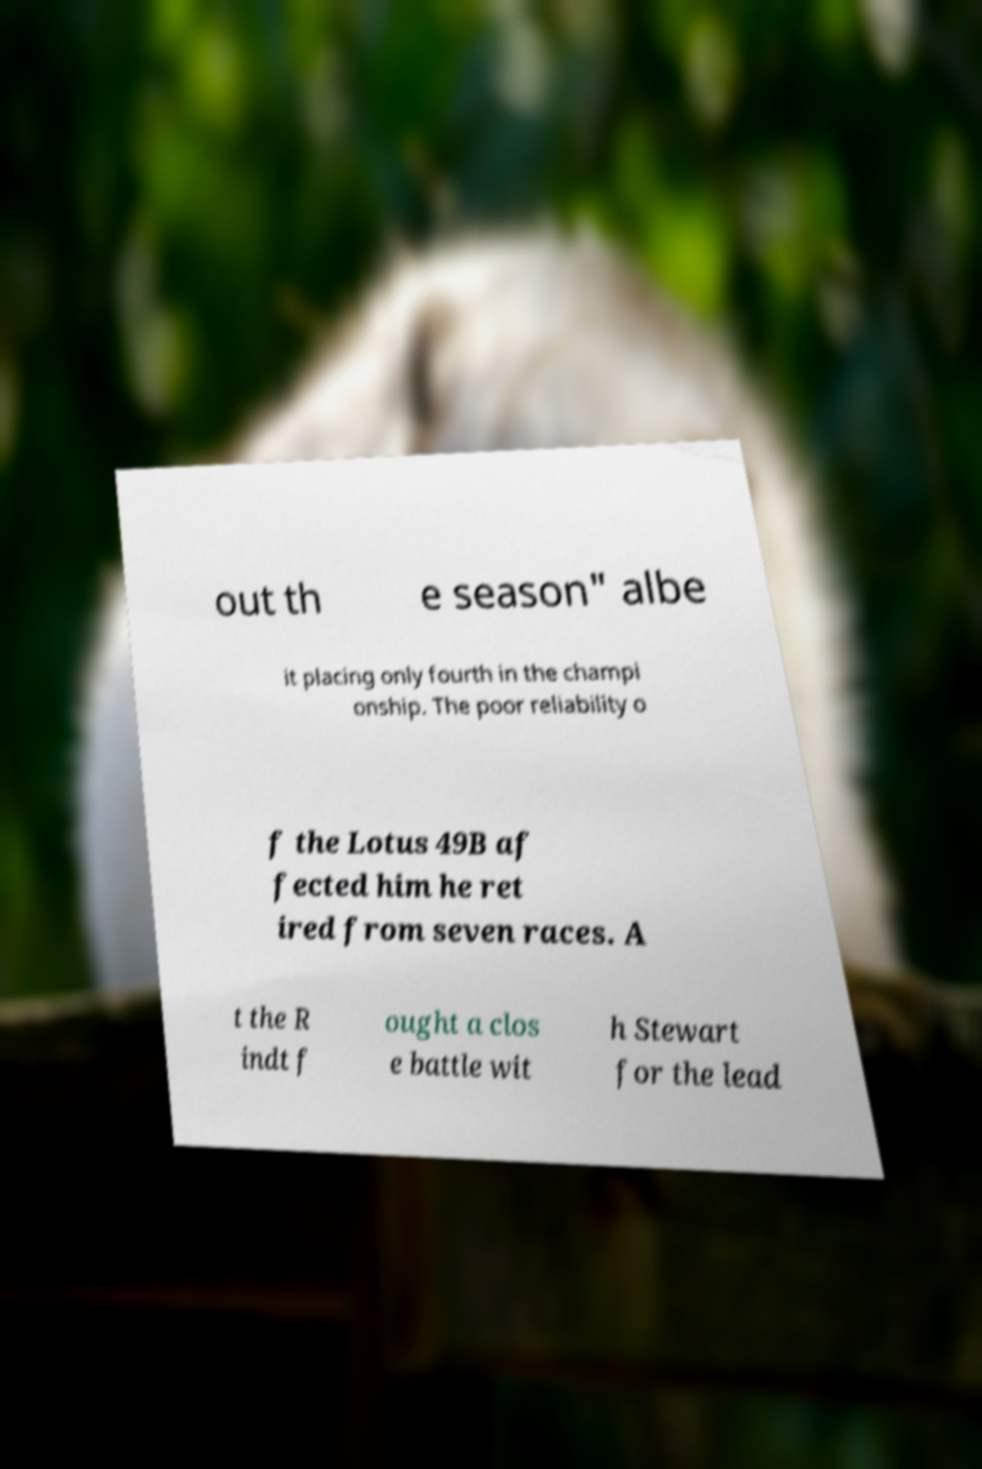Can you accurately transcribe the text from the provided image for me? out th e season" albe it placing only fourth in the champi onship. The poor reliability o f the Lotus 49B af fected him he ret ired from seven races. A t the R indt f ought a clos e battle wit h Stewart for the lead 